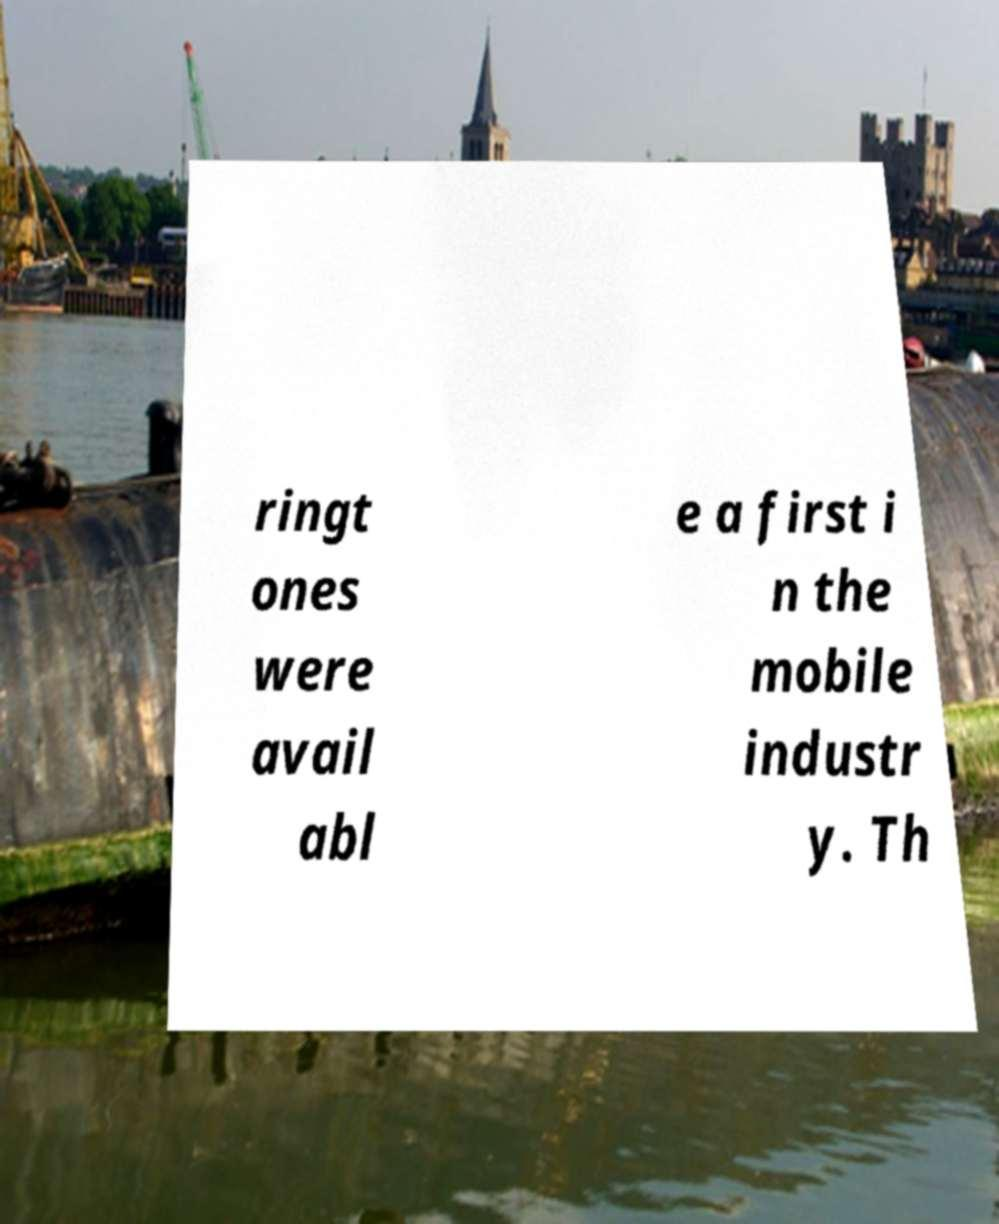I need the written content from this picture converted into text. Can you do that? ringt ones were avail abl e a first i n the mobile industr y. Th 